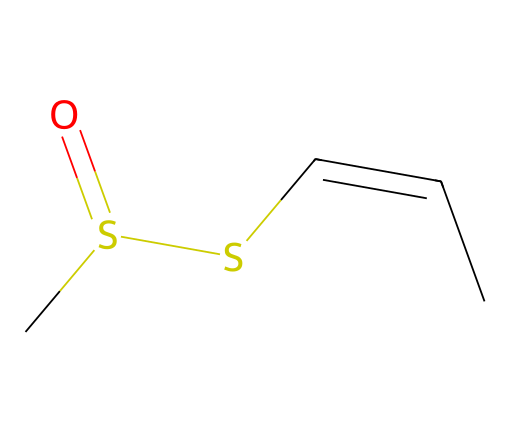What is the main functional group in allicin? The chemical structure has sulfur atoms connected with a carbon chain. The presence of the sulfoxide group (C[S](=O)) indicates the main functional group in the compound is a sulfoxide.
Answer: sulfoxide How many carbon atoms are in allicin? By analyzing the SMILES representation, we can count the number of carbon symbols (C). There are four carbon atoms in the structure as each carbon atom is represented once.
Answer: four What type of compound is allicin? Allicin is characterized by the presence of sulfur along with carbon and hydrogen, fitting the criteria for an organosulfur compound.
Answer: organosulfur What is the degree of unsaturation in allicin? The degree of unsaturation can be determined through the presence of the double bond (C=C) in the structure, indicating at least one degree of unsaturation. There is a double bond and the ring structures (if any) must also be considered; however, here it’s mainly a double bond contributing to one degree.
Answer: one How many sulfur atoms are present in allicin? The SMILES notation indicates two sulfur atoms connected to the carbon chain (C[S](=O)S), therefore there are two sulfur atoms in total.
Answer: two What types of bonds are present between the carbon atoms in allicin? The bonds between the carbon atoms in allicin include single bonds as well as a double bond (C=C), which allows for some unsaturation along the carbon chain. This can be determined by visualizing the connections shown in the SMILES notation.
Answer: single and double bonds What health benefit is primarily associated with allicin? Allicin is commonly linked to potential health benefits such as having antibacterial and anti-inflammatory properties, which are well-documented in research focused on garlic.
Answer: antibacterial 